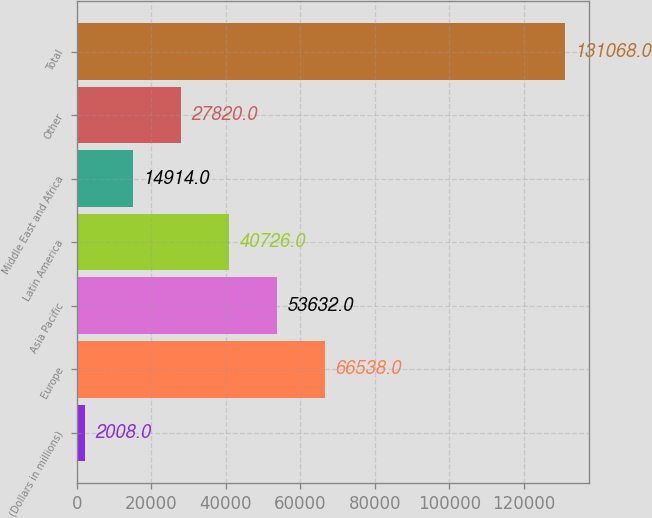<chart> <loc_0><loc_0><loc_500><loc_500><bar_chart><fcel>(Dollars in millions)<fcel>Europe<fcel>Asia Pacific<fcel>Latin America<fcel>Middle East and Africa<fcel>Other<fcel>Total<nl><fcel>2008<fcel>66538<fcel>53632<fcel>40726<fcel>14914<fcel>27820<fcel>131068<nl></chart> 